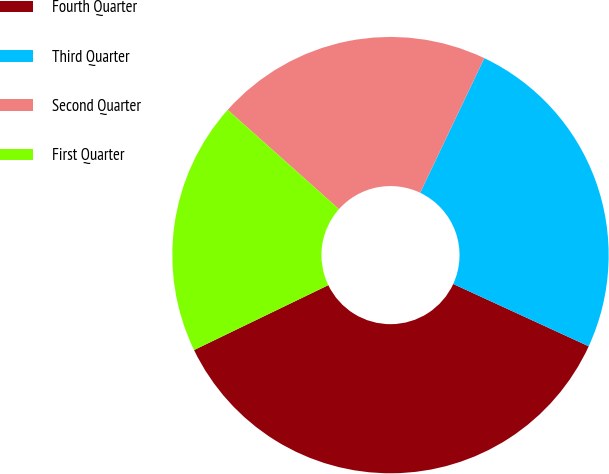<chart> <loc_0><loc_0><loc_500><loc_500><pie_chart><fcel>Fourth Quarter<fcel>Third Quarter<fcel>Second Quarter<fcel>First Quarter<nl><fcel>35.98%<fcel>24.79%<fcel>20.48%<fcel>18.76%<nl></chart> 